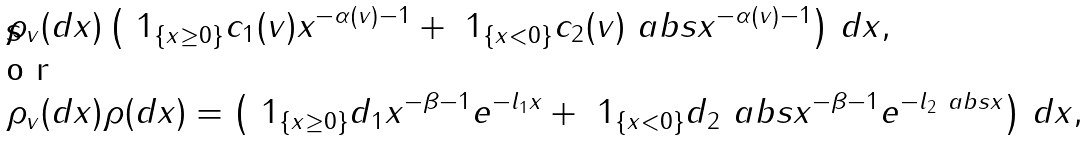Convert formula to latex. <formula><loc_0><loc_0><loc_500><loc_500>\rho _ { v } ( d x ) & \left ( \ 1 _ { \{ x \geq 0 \} } c _ { 1 } ( v ) x ^ { - \alpha ( v ) - 1 } + \ 1 _ { \{ x < 0 \} } c _ { 2 } ( v ) \ a b s { x } ^ { - \alpha ( v ) - 1 } \right ) \, d x , \shortintertext { o r } \rho _ { v } ( d x ) & \rho ( d x ) = \left ( \ 1 _ { \{ x \geq 0 \} } d _ { 1 } x ^ { - \beta - 1 } e ^ { - l _ { 1 } x } + \ 1 _ { \{ x < 0 \} } d _ { 2 } \ a b s { x } ^ { - \beta - 1 } e ^ { - l _ { 2 } \ a b s { x } } \right ) \, d x ,</formula> 